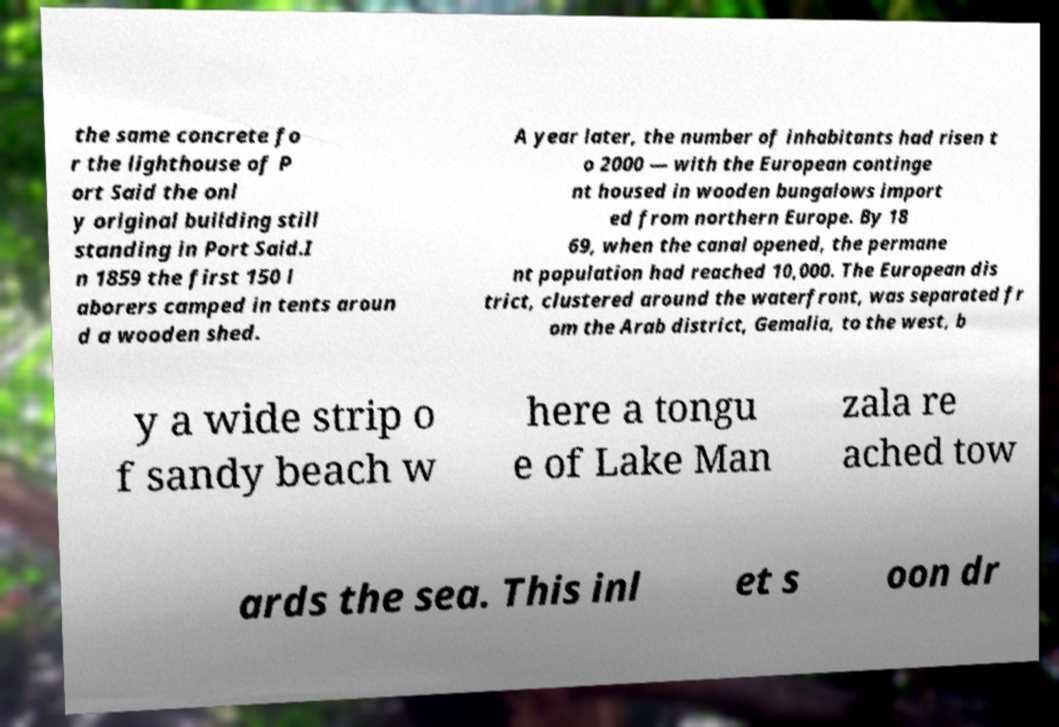Could you assist in decoding the text presented in this image and type it out clearly? the same concrete fo r the lighthouse of P ort Said the onl y original building still standing in Port Said.I n 1859 the first 150 l aborers camped in tents aroun d a wooden shed. A year later, the number of inhabitants had risen t o 2000 — with the European continge nt housed in wooden bungalows import ed from northern Europe. By 18 69, when the canal opened, the permane nt population had reached 10,000. The European dis trict, clustered around the waterfront, was separated fr om the Arab district, Gemalia, to the west, b y a wide strip o f sandy beach w here a tongu e of Lake Man zala re ached tow ards the sea. This inl et s oon dr 